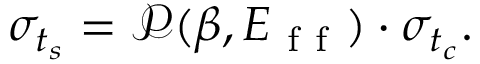<formula> <loc_0><loc_0><loc_500><loc_500>\sigma _ { t _ { s } } = \ m a t h s c r { P } ( \beta , E _ { f f } ) \cdot \sigma _ { t _ { c } } .</formula> 